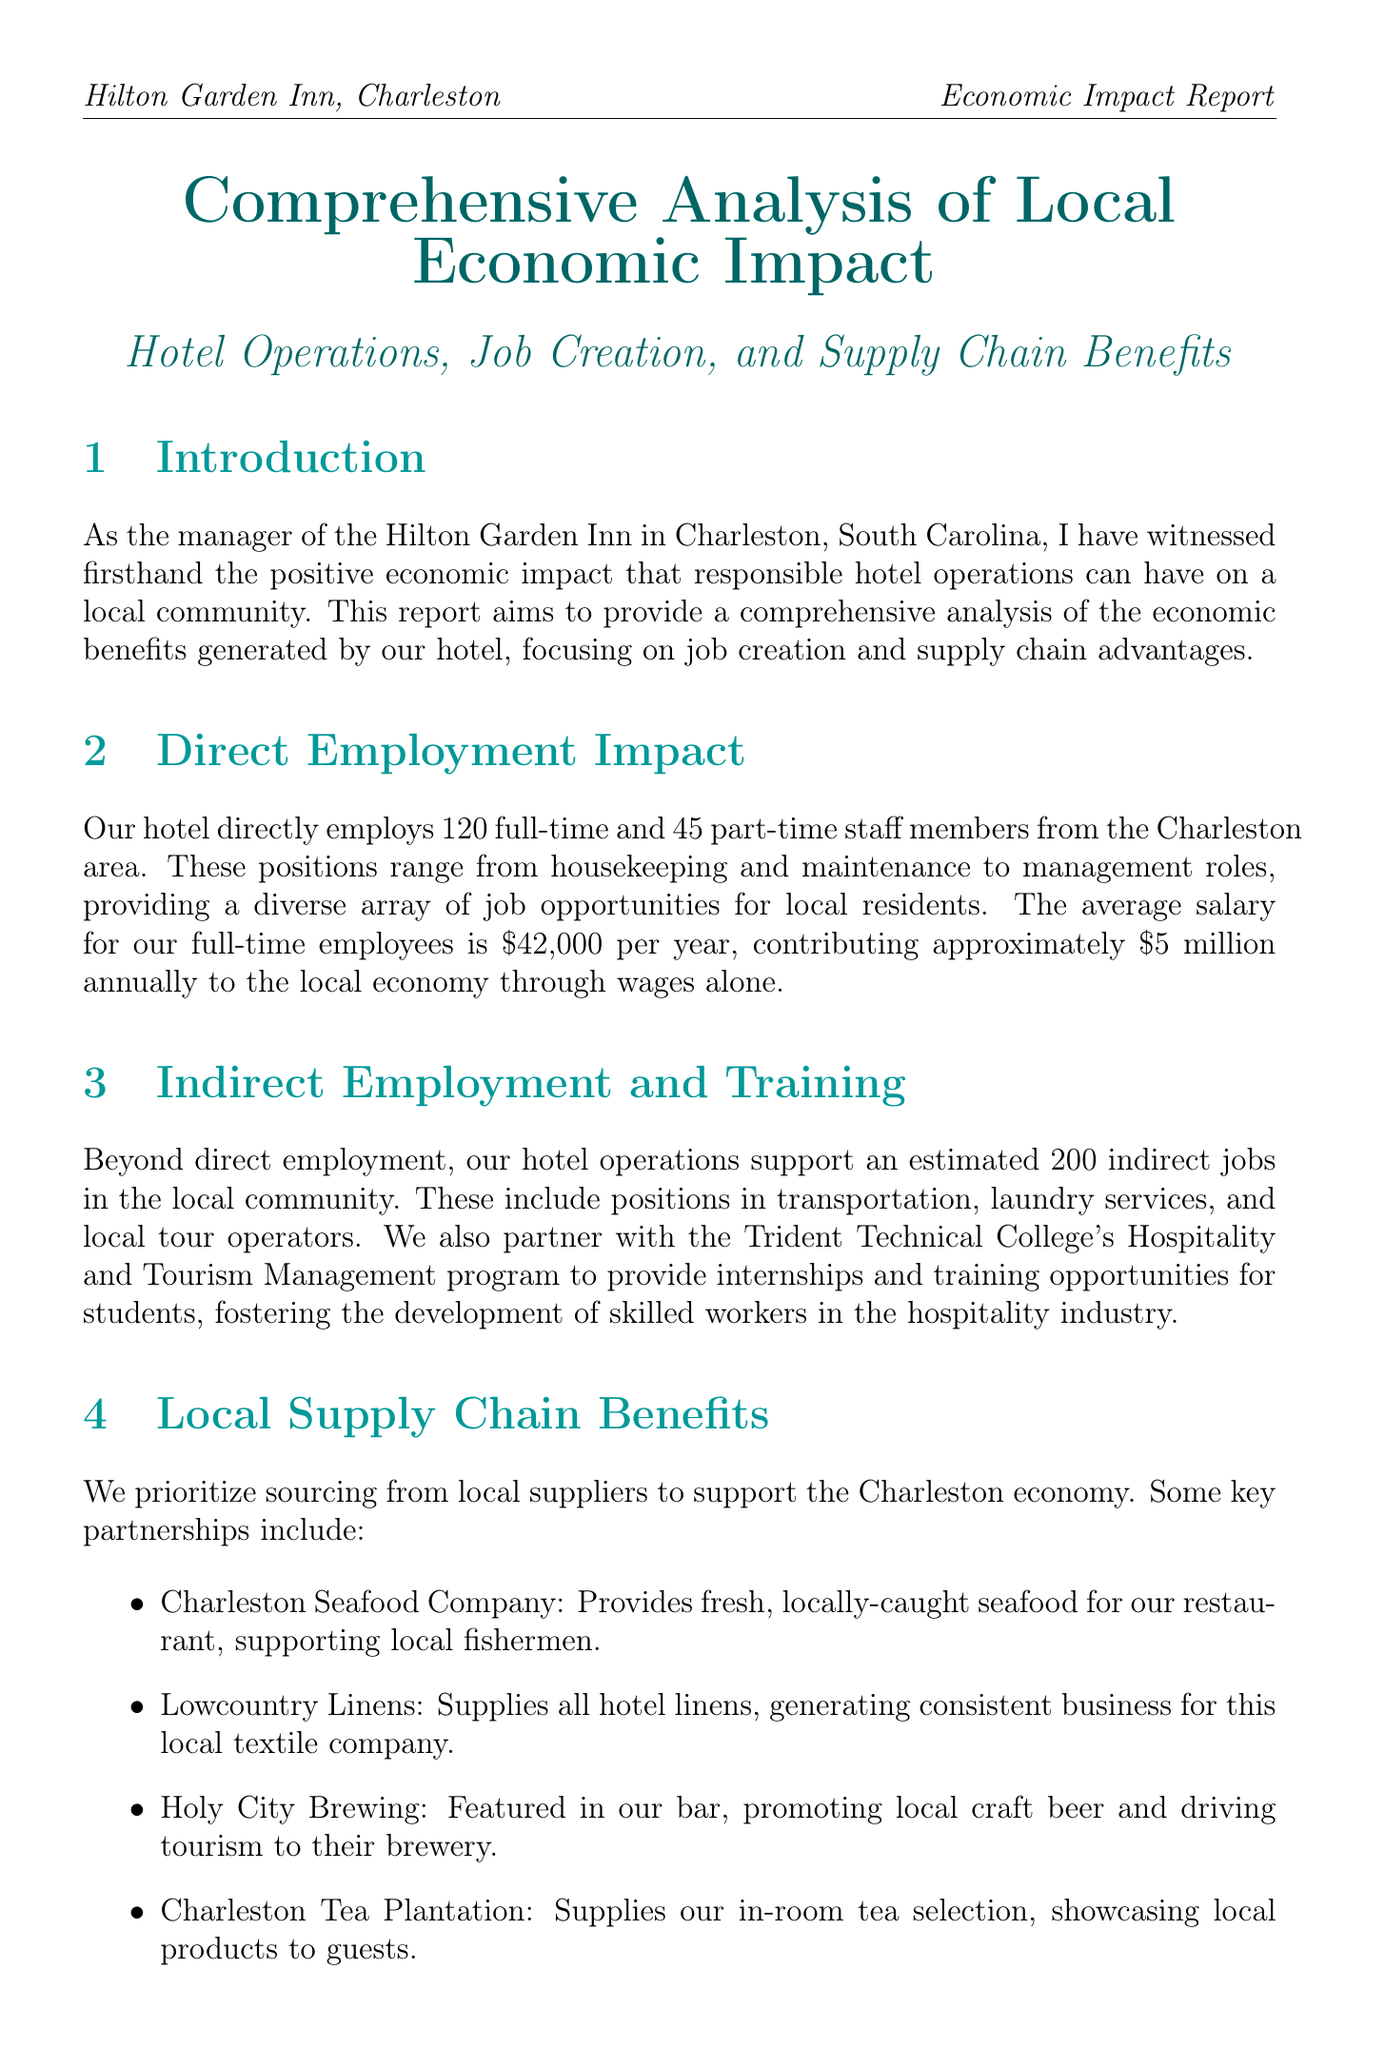What is the total number of direct employees? The document states that the hotel directly employs 120 full-time and 45 part-time staff members. Therefore, the total number of direct employees is 120 + 45.
Answer: 165 How much does the hotel contribute to the local economy through wages? The average salary for full-time employees is $42,000 per year, and with 120 employees, the total contribution through wages is approximately $5 million annually.
Answer: $5 million What is the annual occupancy rate of the hotel? The document mentions an annual occupancy rate of 75%.
Answer: 75% Which local supplier provides linens for the hotel? The hotel sources its linens from Lowcountry Linens, as mentioned in the local supply chain benefits section.
Answer: Lowcountry Linens What is the annual donation amount to the Charleston Parks Conservancy? The report states an annual donation of $50,000 to the Charleston Parks Conservancy.
Answer: $50,000 How many indirect jobs does the hotel support in the community? The hotel operations support an estimated 200 indirect jobs in the local community, according to the document.
Answer: 200 What is the total tax revenue generated by the hotel in the past fiscal year? The hotel paid $1.2 million in property taxes and generated $3.5 million in sales tax revenue, totaling $4.7 million in tax revenue.
Answer: $4.7 million What is the average amount guests spend outside the hotel per day? Guests spend an average of $150 per day outside the hotel on activities such as dining and shopping.
Answer: $150 What sustainable practice involves energy-efficient lighting? The document mentions energy-efficient lighting and HVAC systems as part of the hotel's commitment to sustainability.
Answer: Energy-efficient lighting and HVAC systems 